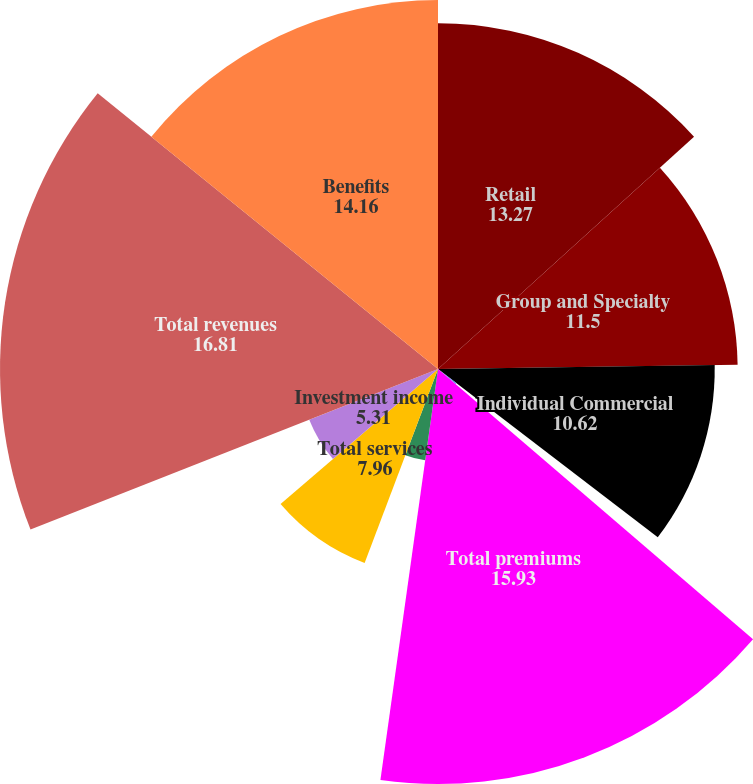Convert chart to OTSL. <chart><loc_0><loc_0><loc_500><loc_500><pie_chart><fcel>Retail<fcel>Group and Specialty<fcel>Individual Commercial<fcel>Other Businesses<fcel>Total premiums<fcel>Healthcare Services<fcel>Total services<fcel>Investment income<fcel>Total revenues<fcel>Benefits<nl><fcel>13.27%<fcel>11.5%<fcel>10.62%<fcel>0.89%<fcel>15.93%<fcel>3.54%<fcel>7.96%<fcel>5.31%<fcel>16.81%<fcel>14.16%<nl></chart> 